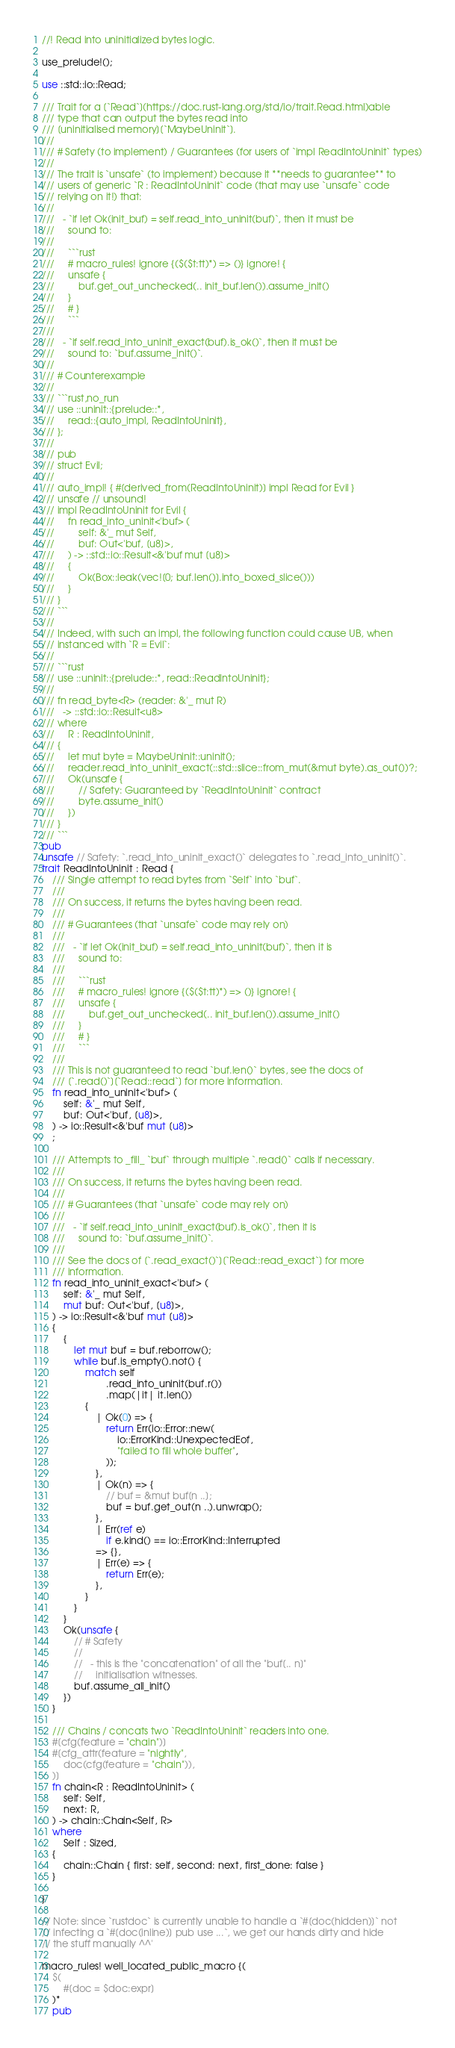Convert code to text. <code><loc_0><loc_0><loc_500><loc_500><_Rust_>//! Read into uninitialized bytes logic.

use_prelude!();

use ::std::io::Read;

/// Trait for a [`Read`](https://doc.rust-lang.org/std/io/trait.Read.html)able
/// type that can output the bytes read into
/// [uninitialised memory][`MaybeUninit`].
///
/// # Safety (to implement) / Guarantees (for users of `impl ReadIntoUninit` types)
///
/// The trait is `unsafe` (to implement) because it **needs to guarantee** to
/// users of generic `R : ReadIntoUninit` code (that may use `unsafe` code
/// relying on it!) that:
///
///   - `if let Ok(init_buf) = self.read_into_uninit(buf)`, then it must be
///     sound to:
///
///     ```rust
///     # macro_rules! ignore {($($t:tt)*) => ()} ignore! {
///     unsafe {
///         buf.get_out_unchecked(.. init_buf.len()).assume_init()
///     }
///     # }
///     ```
///
///   - `if self.read_into_uninit_exact(buf).is_ok()`, then it must be
///     sound to: `buf.assume_init()`.
///
/// # Counterexample
///
/// ```rust,no_run
/// use ::uninit::{prelude::*,
///     read::{auto_impl, ReadIntoUninit},
/// };
///
/// pub
/// struct Evil;
///
/// auto_impl! { #[derived_from(ReadIntoUninit)] impl Read for Evil }
/// unsafe // unsound!
/// impl ReadIntoUninit for Evil {
///     fn read_into_uninit<'buf> (
///         self: &'_ mut Self,
///         buf: Out<'buf, [u8]>,
///     ) -> ::std::io::Result<&'buf mut [u8]>
///     {
///         Ok(Box::leak(vec![0; buf.len()].into_boxed_slice()))
///     }
/// }
/// ```
///
/// Indeed, with such an impl, the following function could cause UB, when
/// instanced with `R = Evil`:
///
/// ```rust
/// use ::uninit::{prelude::*, read::ReadIntoUninit};
///
/// fn read_byte<R> (reader: &'_ mut R)
///   -> ::std::io::Result<u8>
/// where
///     R : ReadIntoUninit,
/// {
///     let mut byte = MaybeUninit::uninit();
///     reader.read_into_uninit_exact(::std::slice::from_mut(&mut byte).as_out())?;
///     Ok(unsafe {
///         // Safety: Guaranteed by `ReadIntoUninit` contract
///         byte.assume_init()
///     })
/// }
/// ```
pub
unsafe // Safety: `.read_into_uninit_exact()` delegates to `.read_into_uninit()`.
trait ReadIntoUninit : Read {
    /// Single attempt to read bytes from `Self` into `buf`.
    ///
    /// On success, it returns the bytes having been read.
    ///
    /// # Guarantees (that `unsafe` code may rely on)
    ///
    ///   - `if let Ok(init_buf) = self.read_into_uninit(buf)`, then it is
    ///     sound to:
    ///
    ///     ```rust
    ///     # macro_rules! ignore {($($t:tt)*) => ()} ignore! {
    ///     unsafe {
    ///         buf.get_out_unchecked(.. init_buf.len()).assume_init()
    ///     }
    ///     # }
    ///     ```
    ///
    /// This is not guaranteed to read `buf.len()` bytes, see the docs of
    /// [`.read()`][`Read::read`] for more information.
    fn read_into_uninit<'buf> (
        self: &'_ mut Self,
        buf: Out<'buf, [u8]>,
    ) -> io::Result<&'buf mut [u8]>
    ;

    /// Attempts to _fill_ `buf` through multiple `.read()` calls if necessary.
    ///
    /// On success, it returns the bytes having been read.
    ///
    /// # Guarantees (that `unsafe` code may rely on)
    ///
    ///   - `if self.read_into_uninit_exact(buf).is_ok()`, then it is
    ///     sound to: `buf.assume_init()`.
    ///
    /// See the docs of [`.read_exact()`][`Read::read_exact`] for more
    /// information.
    fn read_into_uninit_exact<'buf> (
        self: &'_ mut Self,
        mut buf: Out<'buf, [u8]>,
    ) -> io::Result<&'buf mut [u8]>
    {
        {
            let mut buf = buf.reborrow();
            while buf.is_empty().not() {
                match self
                        .read_into_uninit(buf.r())
                        .map(|it| it.len())
                {
                    | Ok(0) => {
                        return Err(io::Error::new(
                            io::ErrorKind::UnexpectedEof,
                            "failed to fill whole buffer",
                        ));
                    },
                    | Ok(n) => {
                        // buf = &mut buf[n ..];
                        buf = buf.get_out(n ..).unwrap();
                    },
                    | Err(ref e)
                        if e.kind() == io::ErrorKind::Interrupted
                    => {},
                    | Err(e) => {
                        return Err(e);
                    },
                }
            }
        }
        Ok(unsafe {
            // # Safety
            //
            //   - this is the "concatenation" of all the "buf[.. n]"
            //     initialisation witnesses.
            buf.assume_all_init()
        })
    }

    /// Chains / concats two `ReadIntoUninit` readers into one.
    #[cfg(feature = "chain")]
    #[cfg_attr(feature = "nightly",
        doc(cfg(feature = "chain")),
    )]
    fn chain<R : ReadIntoUninit> (
        self: Self,
        next: R,
    ) -> chain::Chain<Self, R>
    where
        Self : Sized,
    {
        chain::Chain { first: self, second: next, first_done: false }
    }

}

// Note: since `rustdoc` is currently unable to handle a `#[doc(hidden)]` not
// infecting a `#[doc(inline)] pub use ...`, we get our hands dirty and hide
// the stuff manually ^^'

macro_rules! well_located_public_macro {(
    $(
        #[doc = $doc:expr]
    )*
    pub</code> 